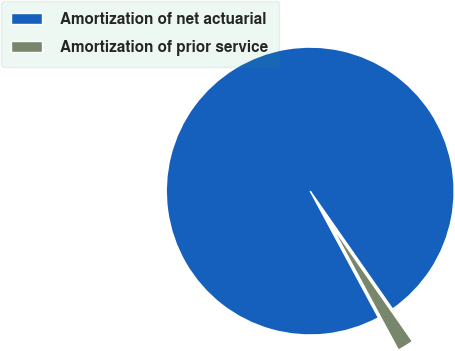Convert chart to OTSL. <chart><loc_0><loc_0><loc_500><loc_500><pie_chart><fcel>Amortization of net actuarial<fcel>Amortization of prior service<nl><fcel>98.17%<fcel>1.83%<nl></chart> 